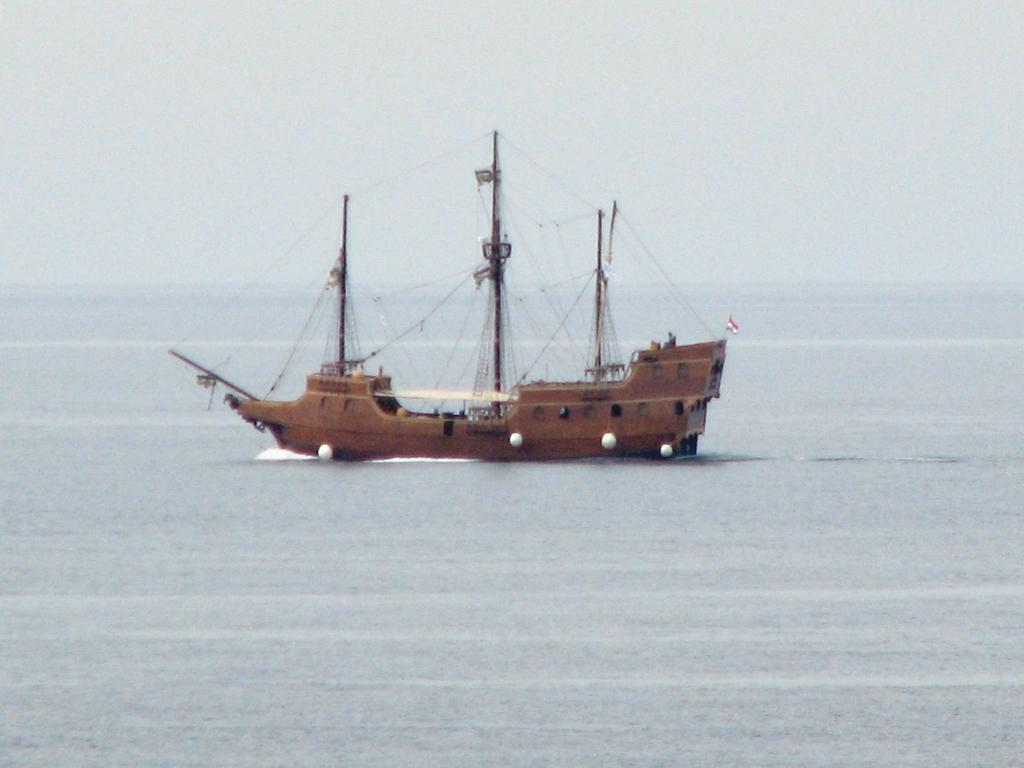Could you give a brief overview of what you see in this image? In this image there is a ship on a sea. 